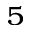Convert formula to latex. <formula><loc_0><loc_0><loc_500><loc_500>_ { 5 }</formula> 